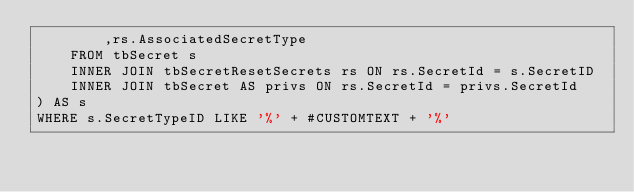<code> <loc_0><loc_0><loc_500><loc_500><_SQL_>        ,rs.AssociatedSecretType
    FROM tbSecret s
    INNER JOIN tbSecretResetSecrets rs ON rs.SecretId = s.SecretID
    INNER JOIN tbSecret AS privs ON rs.SecretId = privs.SecretId
) AS s
WHERE s.SecretTypeID LIKE '%' + #CUSTOMTEXT + '%'</code> 